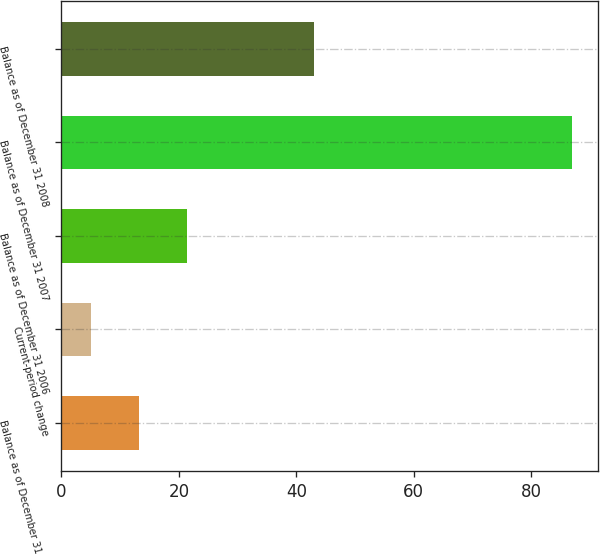Convert chart to OTSL. <chart><loc_0><loc_0><loc_500><loc_500><bar_chart><fcel>Balance as of December 31 2005<fcel>Current-period change<fcel>Balance as of December 31 2006<fcel>Balance as of December 31 2007<fcel>Balance as of December 31 2008<nl><fcel>13.2<fcel>5<fcel>21.4<fcel>87<fcel>43<nl></chart> 